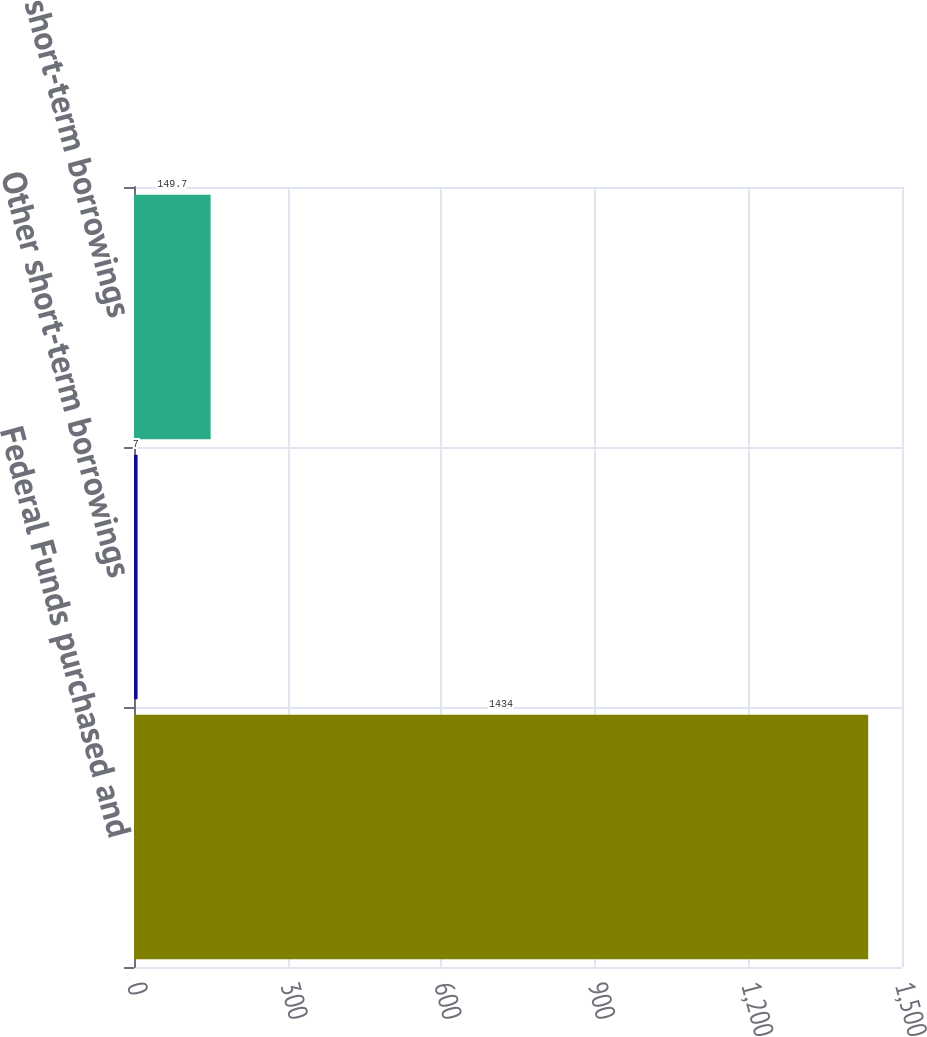Convert chart. <chart><loc_0><loc_0><loc_500><loc_500><bar_chart><fcel>Federal Funds purchased and<fcel>Other short-term borrowings<fcel>61 Other short-term borrowings<nl><fcel>1434<fcel>7<fcel>149.7<nl></chart> 